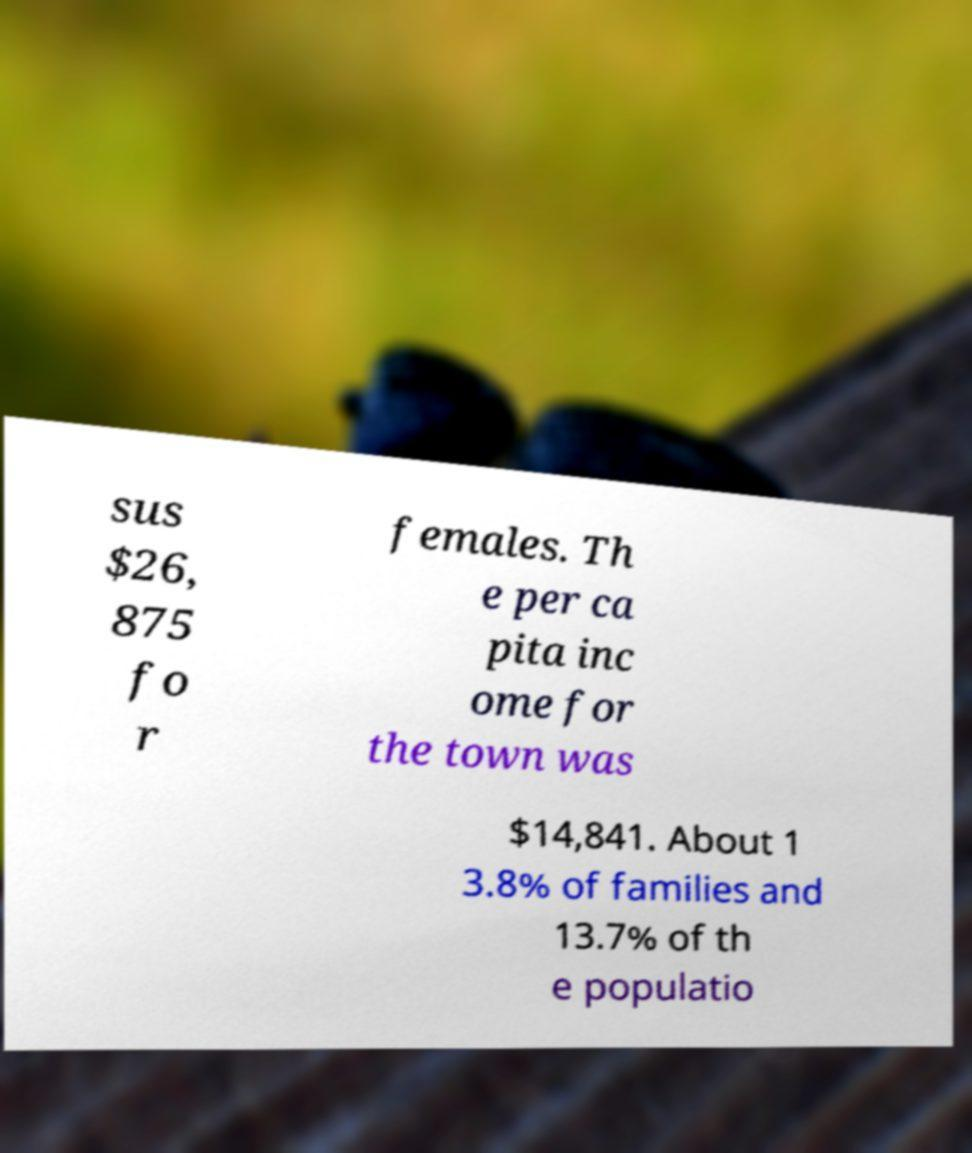Can you accurately transcribe the text from the provided image for me? sus $26, 875 fo r females. Th e per ca pita inc ome for the town was $14,841. About 1 3.8% of families and 13.7% of th e populatio 